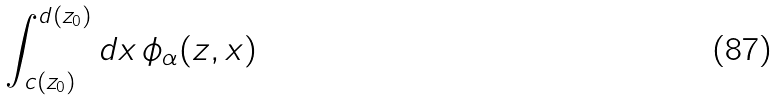<formula> <loc_0><loc_0><loc_500><loc_500>\int _ { c ( z _ { 0 } ) } ^ { d ( z _ { 0 } ) } d x \, \phi _ { \alpha } ( z , x )</formula> 